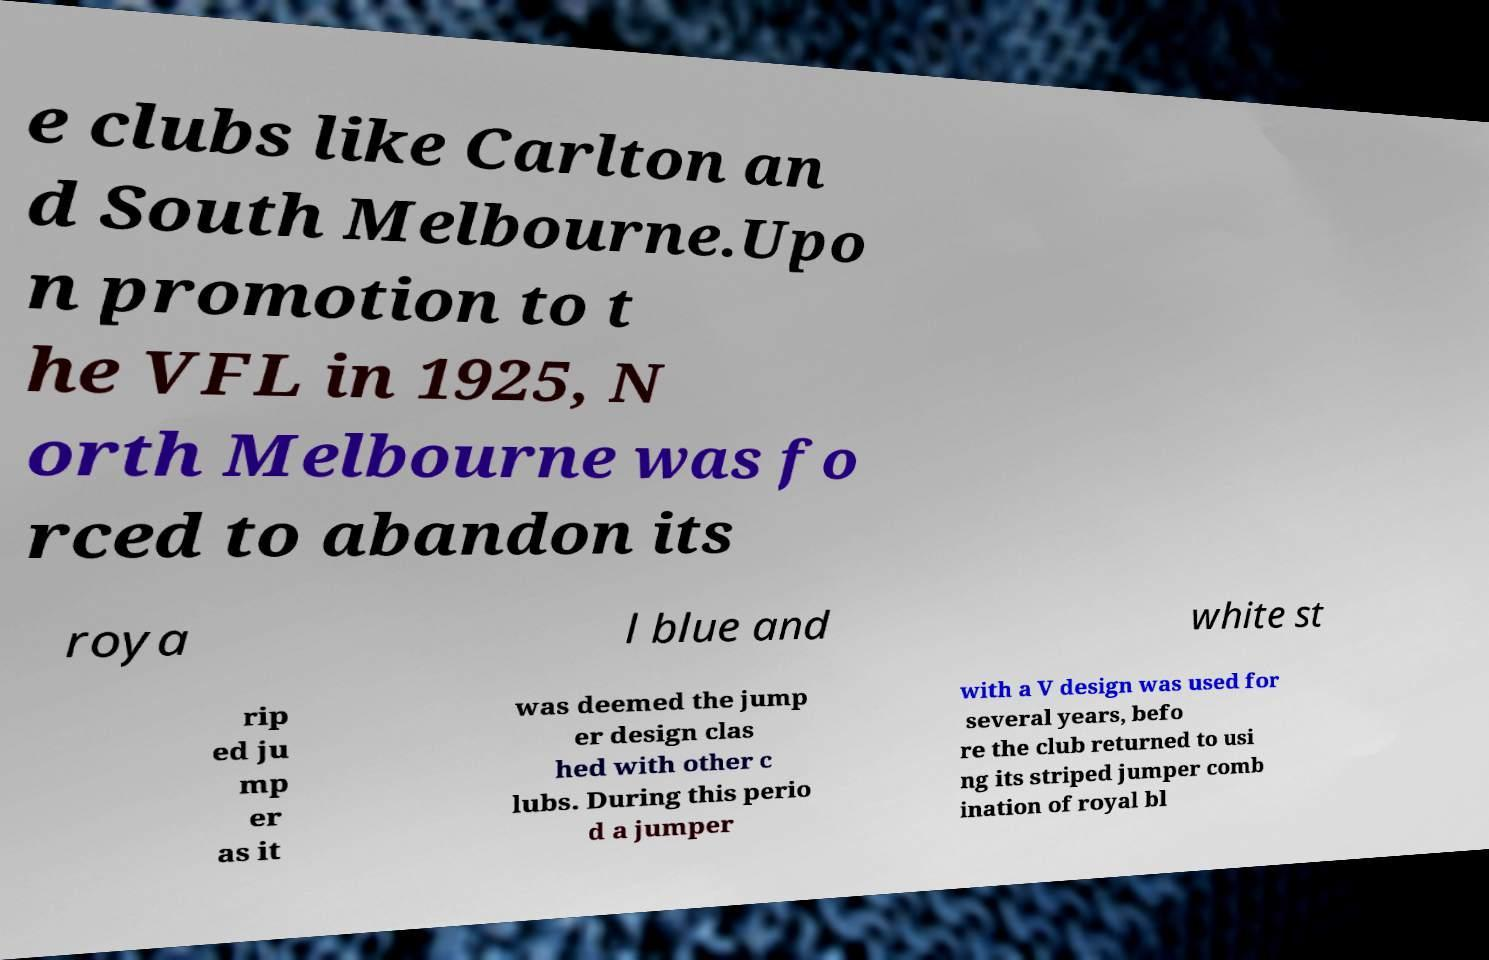Could you assist in decoding the text presented in this image and type it out clearly? e clubs like Carlton an d South Melbourne.Upo n promotion to t he VFL in 1925, N orth Melbourne was fo rced to abandon its roya l blue and white st rip ed ju mp er as it was deemed the jump er design clas hed with other c lubs. During this perio d a jumper with a V design was used for several years, befo re the club returned to usi ng its striped jumper comb ination of royal bl 